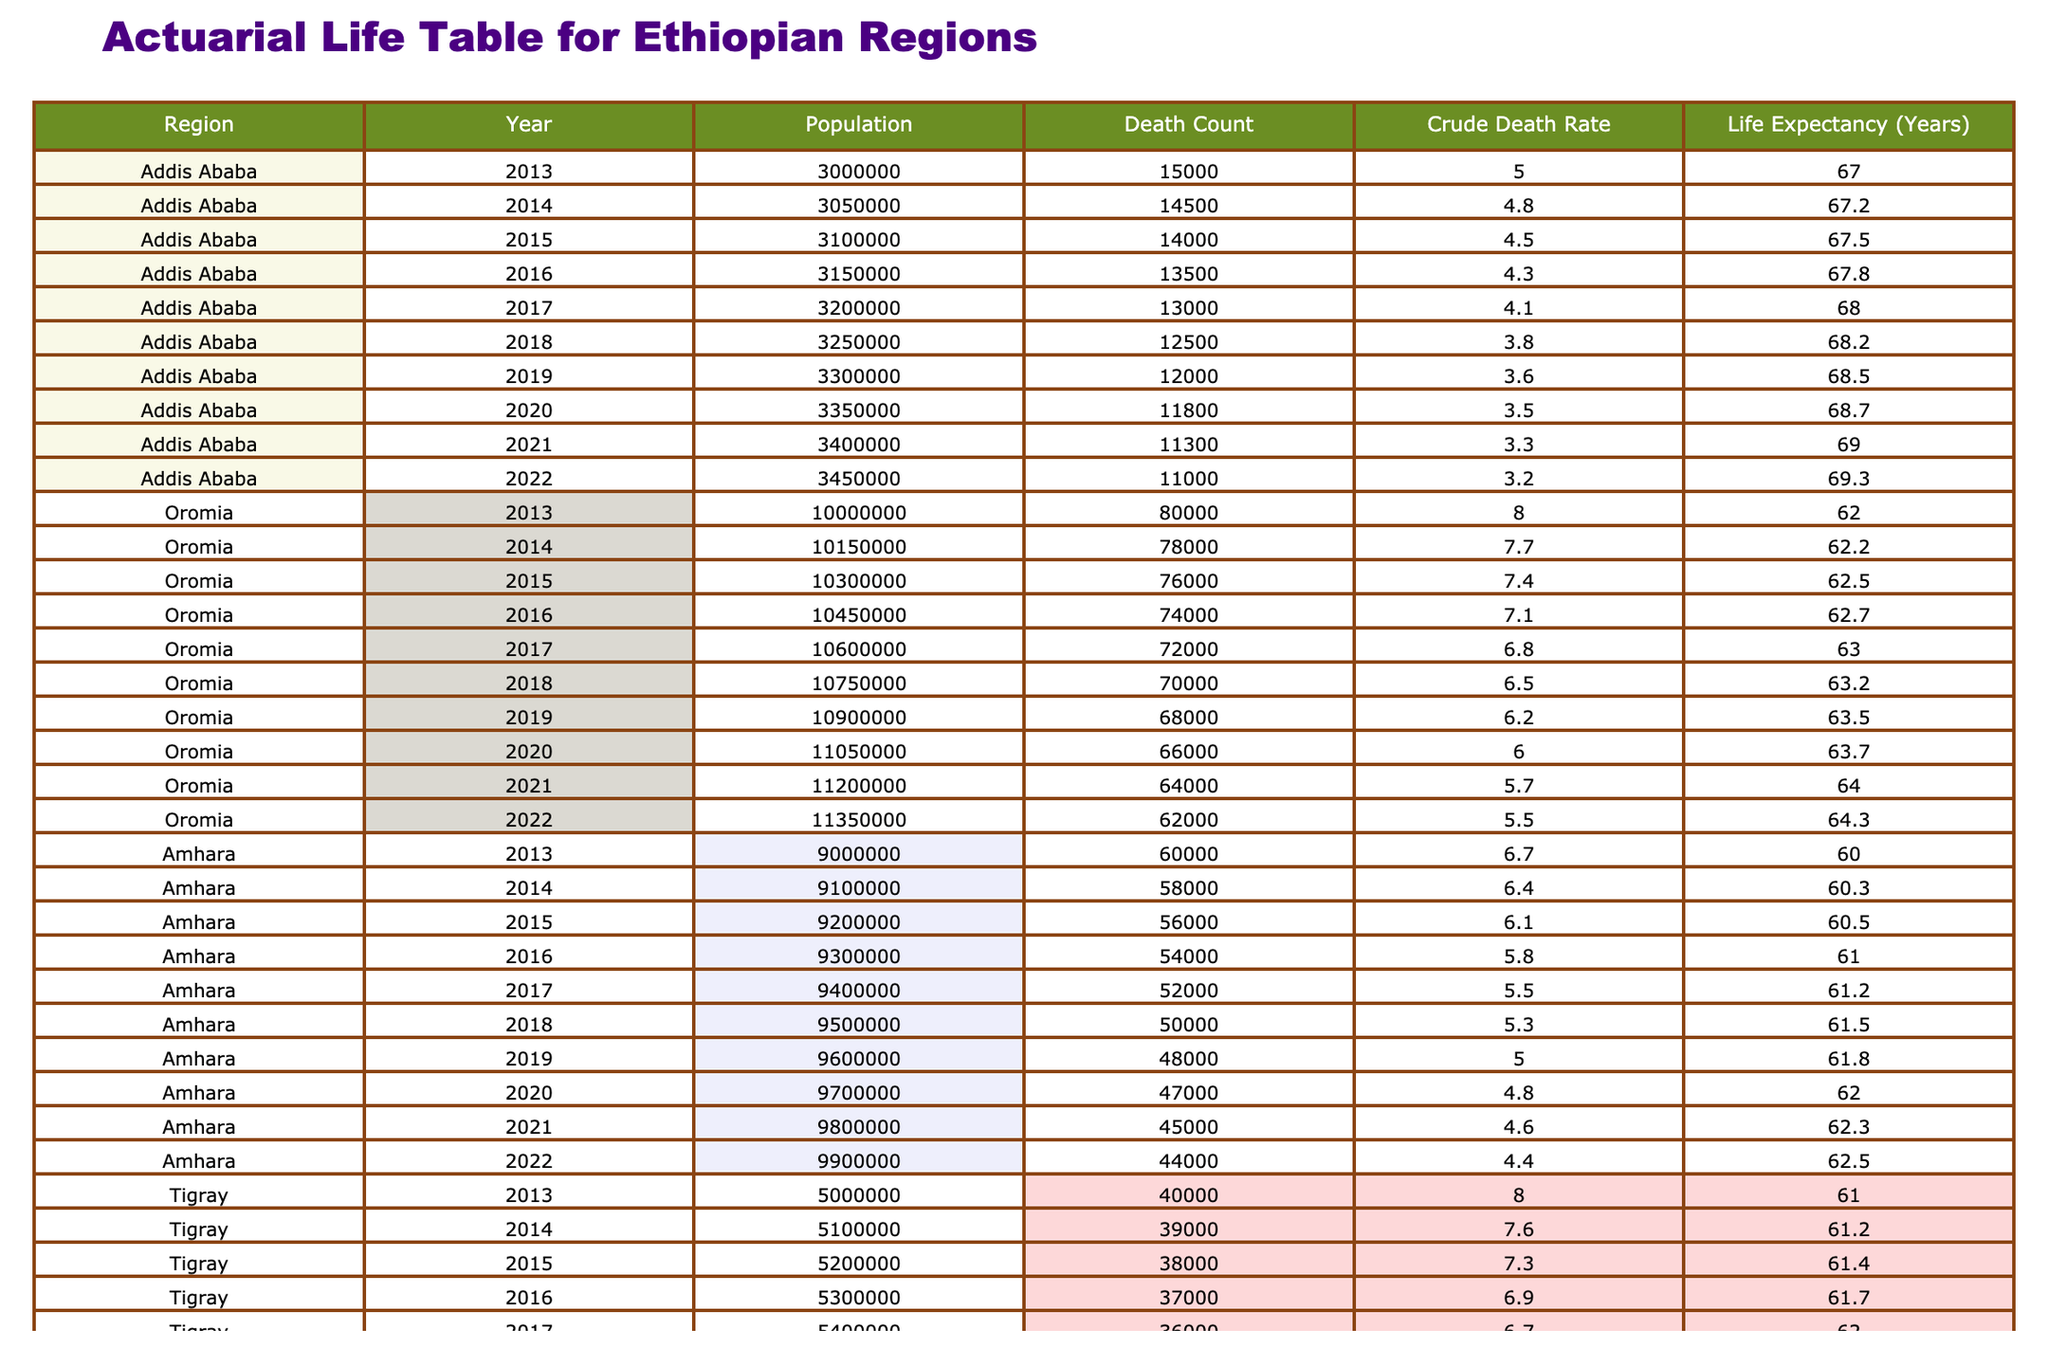What was the Crude Death Rate in Oromia in 2022? The table shows the Crude Death Rate for various regions and years. For Oromia in 2022, the Crude Death Rate is listed in the table as 5.5.
Answer: 5.5 Which region had the highest Life Expectancy in 2021? Examining the Life Expectancy column for the year 2021 across all regions, Addis Ababa has the highest Life Expectancy of 69 years.
Answer: Addis Ababa What is the total Death Count for Amhara from 2013 to 2022? To find the total Death Count for Amhara, we sum the values from 2013 to 2022: 60000 + 58000 + 56000 + 54000 + 52000 + 50000 + 48000 + 47000 + 45000 + 44000 =  479000.
Answer: 479000 Is the Crude Death Rate for Tigray decreasing from 2013 to 2022? By reviewing the Crude Death Rate values for Tigray from 2013 (8.0) to 2022 (5.3), we can see that it has consistently decreased over the years.
Answer: Yes What was the average Life Expectancy in Addis Ababa from 2013 to 2022? To calculate the average Life Expectancy for Addis Ababa, we add the values from each year (67 + 67.2 + 67.5 + 67.8 + 68 + 68.2 + 68.5 + 68.7 + 69 + 69.3) and divide by 10. The sum is 681.2, leading to an average of 68.12 years.
Answer: 68.12 In which year did the Death Count in Oromia drop below 70000? Reviewing the Death Count for Oromia, it dropped below 70000 in 2019 when it was 68000.
Answer: 2019 What is the trend in the Crude Death Rate for Addis Ababa from 2013 to 2022? Looking at the Crude Death Rate for Addis Ababa from 2013 (5.0) to 2022 (3.2), the values show a consistent decrease over the years.
Answer: Decreasing What was the Crude Death Rate in Ethiopia's regions in 2013? Reviewing the table for the year 2013, the Crude Death Rates are as follows: Addis Ababa (5.0), Oromia (8.0), Amhara (6.7), and Tigray (8.0).
Answer: 5.0, 8.0, 6.7, 8.0 